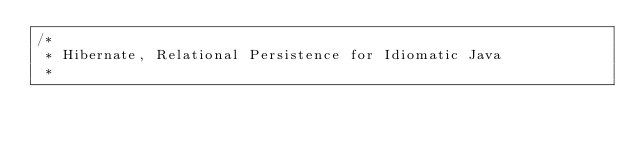Convert code to text. <code><loc_0><loc_0><loc_500><loc_500><_Java_>/*
 * Hibernate, Relational Persistence for Idiomatic Java
 *</code> 